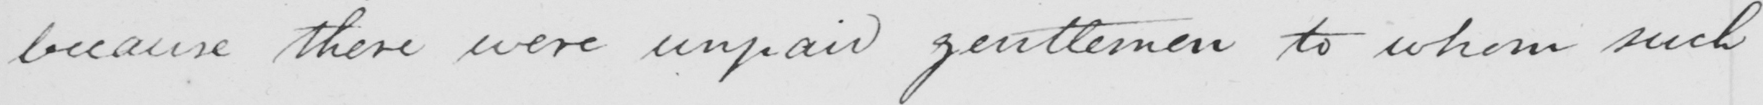Transcribe the text shown in this historical manuscript line. because there were unpaid gentlemen to whom such 